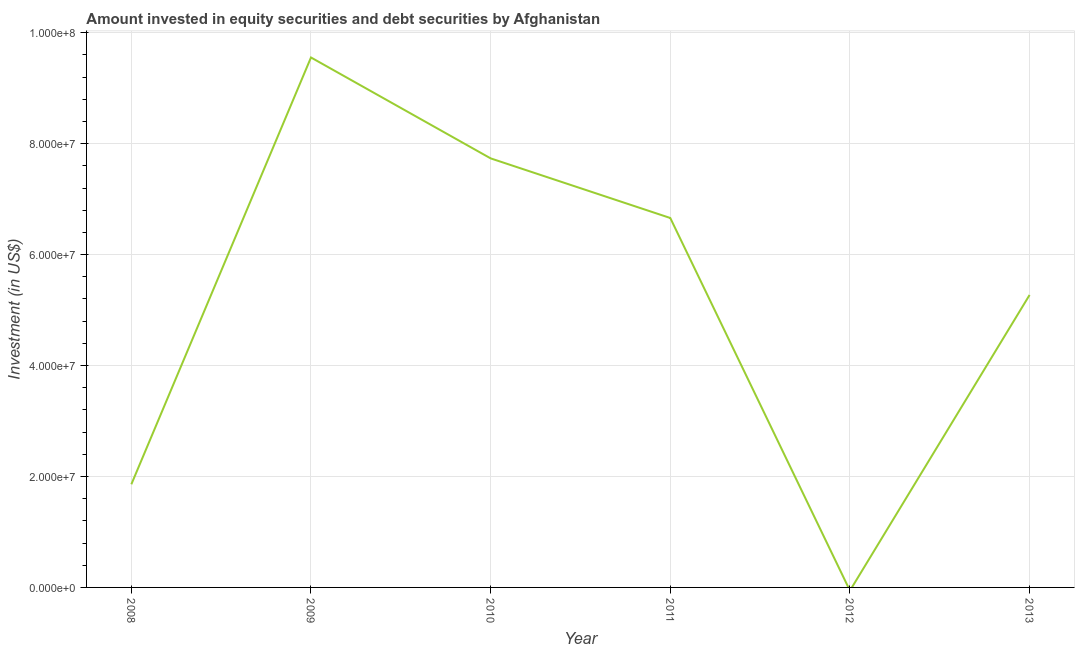What is the portfolio investment in 2013?
Ensure brevity in your answer.  5.27e+07. Across all years, what is the maximum portfolio investment?
Give a very brief answer. 9.55e+07. In which year was the portfolio investment maximum?
Make the answer very short. 2009. What is the sum of the portfolio investment?
Your response must be concise. 3.11e+08. What is the difference between the portfolio investment in 2010 and 2011?
Your response must be concise. 1.07e+07. What is the average portfolio investment per year?
Make the answer very short. 5.18e+07. What is the median portfolio investment?
Give a very brief answer. 5.97e+07. In how many years, is the portfolio investment greater than 40000000 US$?
Your answer should be compact. 4. What is the ratio of the portfolio investment in 2008 to that in 2011?
Ensure brevity in your answer.  0.28. Is the portfolio investment in 2008 less than that in 2013?
Ensure brevity in your answer.  Yes. Is the difference between the portfolio investment in 2010 and 2011 greater than the difference between any two years?
Your answer should be compact. No. What is the difference between the highest and the second highest portfolio investment?
Provide a short and direct response. 1.82e+07. What is the difference between the highest and the lowest portfolio investment?
Your response must be concise. 9.55e+07. In how many years, is the portfolio investment greater than the average portfolio investment taken over all years?
Provide a succinct answer. 4. What is the difference between two consecutive major ticks on the Y-axis?
Provide a short and direct response. 2.00e+07. Does the graph contain any zero values?
Your answer should be compact. Yes. Does the graph contain grids?
Provide a short and direct response. Yes. What is the title of the graph?
Your answer should be compact. Amount invested in equity securities and debt securities by Afghanistan. What is the label or title of the Y-axis?
Your response must be concise. Investment (in US$). What is the Investment (in US$) in 2008?
Make the answer very short. 1.86e+07. What is the Investment (in US$) of 2009?
Make the answer very short. 9.55e+07. What is the Investment (in US$) in 2010?
Your answer should be compact. 7.73e+07. What is the Investment (in US$) of 2011?
Your response must be concise. 6.66e+07. What is the Investment (in US$) in 2013?
Your response must be concise. 5.27e+07. What is the difference between the Investment (in US$) in 2008 and 2009?
Make the answer very short. -7.69e+07. What is the difference between the Investment (in US$) in 2008 and 2010?
Keep it short and to the point. -5.88e+07. What is the difference between the Investment (in US$) in 2008 and 2011?
Your response must be concise. -4.80e+07. What is the difference between the Investment (in US$) in 2008 and 2013?
Offer a very short reply. -3.41e+07. What is the difference between the Investment (in US$) in 2009 and 2010?
Keep it short and to the point. 1.82e+07. What is the difference between the Investment (in US$) in 2009 and 2011?
Offer a terse response. 2.89e+07. What is the difference between the Investment (in US$) in 2009 and 2013?
Your response must be concise. 4.28e+07. What is the difference between the Investment (in US$) in 2010 and 2011?
Offer a terse response. 1.07e+07. What is the difference between the Investment (in US$) in 2010 and 2013?
Your answer should be very brief. 2.46e+07. What is the difference between the Investment (in US$) in 2011 and 2013?
Your response must be concise. 1.39e+07. What is the ratio of the Investment (in US$) in 2008 to that in 2009?
Your answer should be compact. 0.2. What is the ratio of the Investment (in US$) in 2008 to that in 2010?
Your answer should be compact. 0.24. What is the ratio of the Investment (in US$) in 2008 to that in 2011?
Offer a very short reply. 0.28. What is the ratio of the Investment (in US$) in 2008 to that in 2013?
Provide a succinct answer. 0.35. What is the ratio of the Investment (in US$) in 2009 to that in 2010?
Offer a terse response. 1.24. What is the ratio of the Investment (in US$) in 2009 to that in 2011?
Your answer should be compact. 1.44. What is the ratio of the Investment (in US$) in 2009 to that in 2013?
Provide a succinct answer. 1.81. What is the ratio of the Investment (in US$) in 2010 to that in 2011?
Offer a terse response. 1.16. What is the ratio of the Investment (in US$) in 2010 to that in 2013?
Make the answer very short. 1.47. What is the ratio of the Investment (in US$) in 2011 to that in 2013?
Keep it short and to the point. 1.26. 